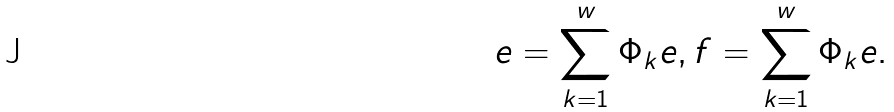<formula> <loc_0><loc_0><loc_500><loc_500>e = \sum ^ { w } _ { k = 1 } \Phi _ { k } e , f = \sum ^ { w } _ { k = 1 } \Phi _ { k } e .</formula> 